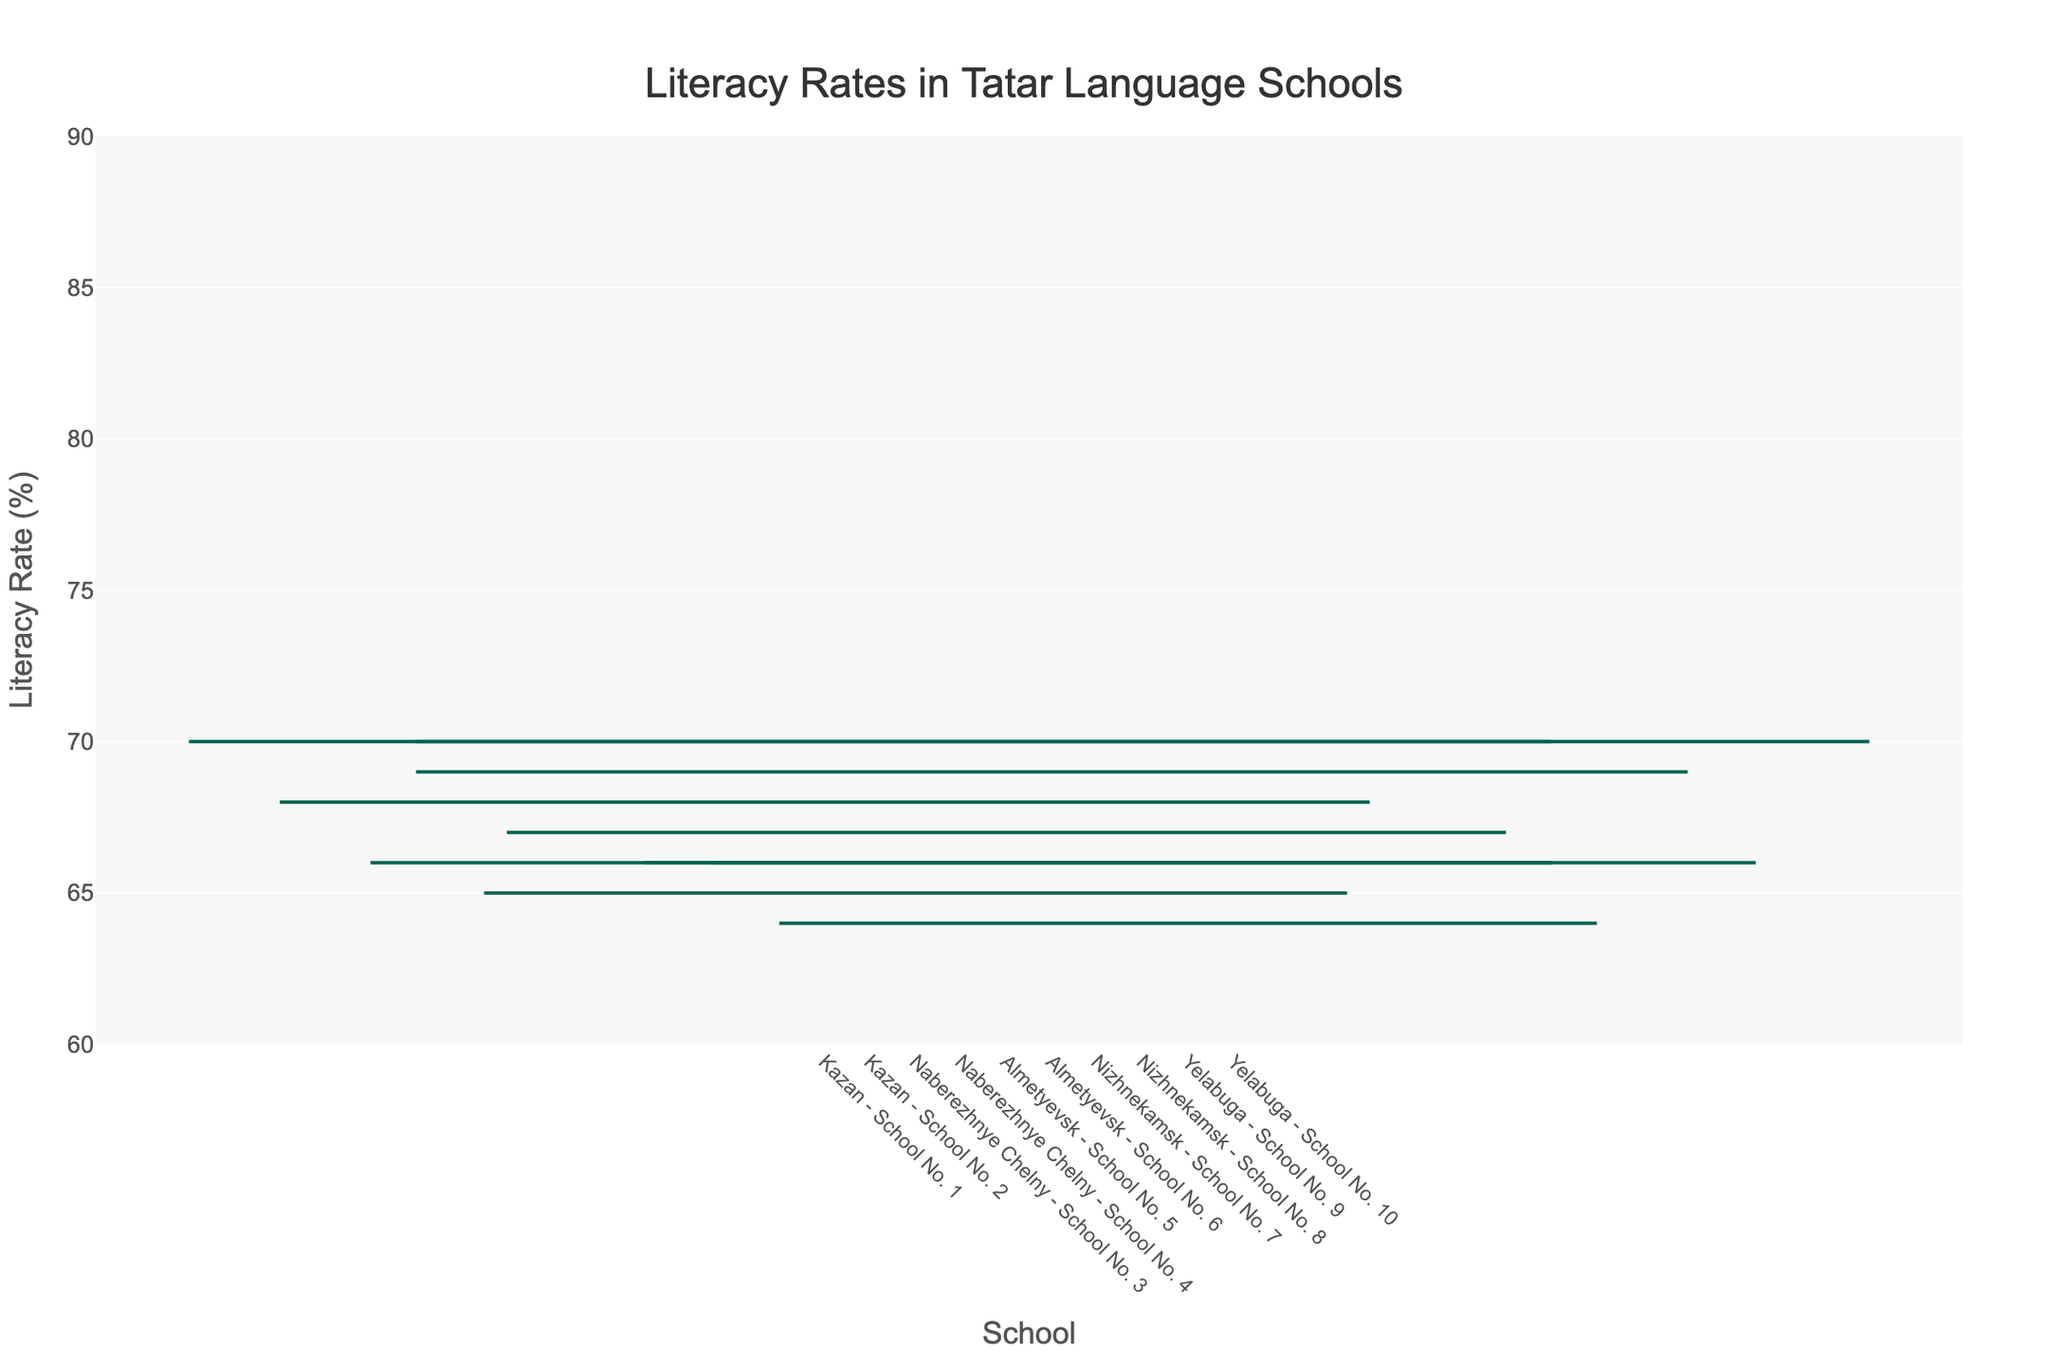Which school in Kazan has the higher median literacy rate? Observe the median values for the two schools in Kazan. School No. 2 has a median literacy rate of 77% while School No. 1 has a median literacy rate of 75%.
Answer: School No. 2 What is the median literacy rate for School No. 7 in Nizhnekamsk? Check the median value for School No. 7 in Nizhnekamsk, which is 73%.
Answer: 73% Which region has the widest variability in literacy rates? Compare the ranges (Max-Min) of literacy rates for all regions. Yelabuga, with schools having ranges of 15% and 18%, shows the largest variability as 18% is the widest.
Answer: Yelabuga Which school has the highest maximum literacy rate? Look at the maximum literacy rates across all schools. School No. 8 in Nizhnekamsk has the highest maximum at 87%.
Answer: School No. 8 What's the difference in the median literacy rates between School No. 5 and School No. 6 in Almetyevsk? Subtract the median literacy rates: School No. 6 (76%) and School No. 5 (75%) results in 1%.
Answer: 1% What is the interquartile range (IQR) for School No. 9 in Yelabuga? Calculate the difference between Q3 and Q1 for School No. 9: 75% - 68% = 7%.
Answer: 7% Compare the widths of boxes for schools in Kazan; which one has more students enrolled? The width of School No. 2's box is wider, indicating more students enrolled compared to School No. 1.
Answer: School No. 2 What is the Q1 literacy rate for School No. 4 in Naberezhnye Chelny? Check the Q1 value for School No. 4, which is 71%.
Answer: 71% How does the box width of School No. 8 in Nizhnekamsk compare to School No. 7, and what does it imply? School No. 8 has a wider box width indicating more students enrolled (160 vs. 100).
Answer: School No. 8 has more students enrolled What is the average of the median literacy rates across all schools? First, sum the median literacy rates (75 + 77 + 73 + 74 + 75 + 76 + 73 + 78 + 72 + 74 = 747) and divide by the number of schools (10), resulting in 74.7%.
Answer: 74.7% 